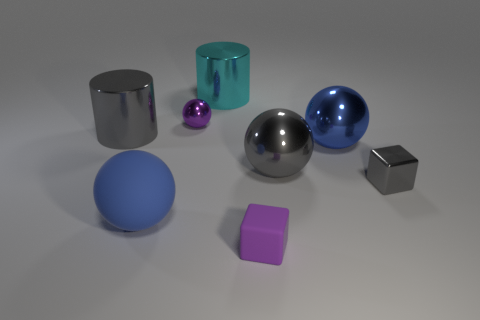Add 1 purple matte cubes. How many objects exist? 9 Subtract all cylinders. How many objects are left? 6 Subtract all blue cubes. Subtract all big gray spheres. How many objects are left? 7 Add 2 blue things. How many blue things are left? 4 Add 8 yellow metal cylinders. How many yellow metal cylinders exist? 8 Subtract 1 gray cubes. How many objects are left? 7 